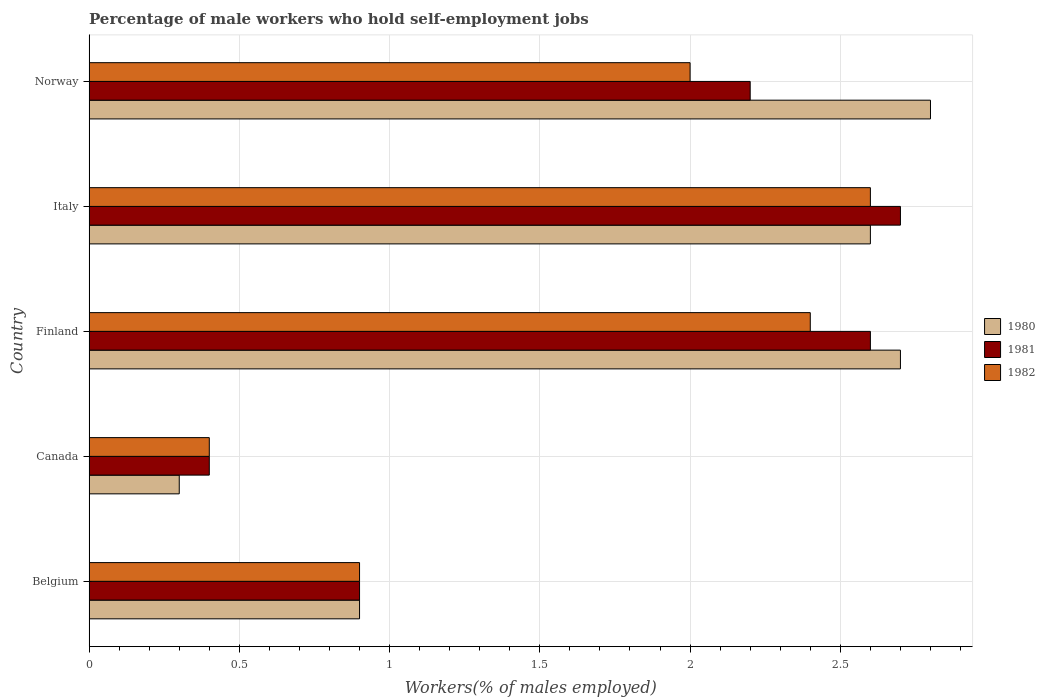How many bars are there on the 2nd tick from the bottom?
Give a very brief answer. 3. What is the label of the 1st group of bars from the top?
Your answer should be very brief. Norway. What is the percentage of self-employed male workers in 1982 in Canada?
Make the answer very short. 0.4. Across all countries, what is the maximum percentage of self-employed male workers in 1982?
Your response must be concise. 2.6. Across all countries, what is the minimum percentage of self-employed male workers in 1980?
Make the answer very short. 0.3. In which country was the percentage of self-employed male workers in 1980 maximum?
Your answer should be very brief. Norway. In which country was the percentage of self-employed male workers in 1981 minimum?
Your response must be concise. Canada. What is the total percentage of self-employed male workers in 1981 in the graph?
Your answer should be compact. 8.8. What is the difference between the percentage of self-employed male workers in 1981 in Belgium and that in Italy?
Your answer should be compact. -1.8. What is the difference between the percentage of self-employed male workers in 1981 in Italy and the percentage of self-employed male workers in 1980 in Norway?
Offer a terse response. -0.1. What is the average percentage of self-employed male workers in 1981 per country?
Make the answer very short. 1.76. What is the difference between the percentage of self-employed male workers in 1981 and percentage of self-employed male workers in 1980 in Norway?
Provide a succinct answer. -0.6. In how many countries, is the percentage of self-employed male workers in 1981 greater than 1.1 %?
Give a very brief answer. 3. What is the ratio of the percentage of self-employed male workers in 1982 in Finland to that in Italy?
Offer a terse response. 0.92. What is the difference between the highest and the second highest percentage of self-employed male workers in 1982?
Keep it short and to the point. 0.2. What is the difference between the highest and the lowest percentage of self-employed male workers in 1981?
Your answer should be very brief. 2.3. In how many countries, is the percentage of self-employed male workers in 1981 greater than the average percentage of self-employed male workers in 1981 taken over all countries?
Your response must be concise. 3. Is the sum of the percentage of self-employed male workers in 1981 in Finland and Norway greater than the maximum percentage of self-employed male workers in 1980 across all countries?
Offer a terse response. Yes. What does the 3rd bar from the bottom in Norway represents?
Provide a succinct answer. 1982. How many countries are there in the graph?
Keep it short and to the point. 5. What is the difference between two consecutive major ticks on the X-axis?
Ensure brevity in your answer.  0.5. Are the values on the major ticks of X-axis written in scientific E-notation?
Your answer should be compact. No. Does the graph contain grids?
Your answer should be very brief. Yes. Where does the legend appear in the graph?
Your answer should be compact. Center right. How are the legend labels stacked?
Give a very brief answer. Vertical. What is the title of the graph?
Provide a short and direct response. Percentage of male workers who hold self-employment jobs. What is the label or title of the X-axis?
Provide a succinct answer. Workers(% of males employed). What is the label or title of the Y-axis?
Offer a very short reply. Country. What is the Workers(% of males employed) in 1980 in Belgium?
Provide a succinct answer. 0.9. What is the Workers(% of males employed) in 1981 in Belgium?
Your answer should be compact. 0.9. What is the Workers(% of males employed) of 1982 in Belgium?
Keep it short and to the point. 0.9. What is the Workers(% of males employed) of 1980 in Canada?
Provide a short and direct response. 0.3. What is the Workers(% of males employed) of 1981 in Canada?
Ensure brevity in your answer.  0.4. What is the Workers(% of males employed) of 1982 in Canada?
Offer a very short reply. 0.4. What is the Workers(% of males employed) of 1980 in Finland?
Ensure brevity in your answer.  2.7. What is the Workers(% of males employed) in 1981 in Finland?
Your answer should be very brief. 2.6. What is the Workers(% of males employed) of 1982 in Finland?
Ensure brevity in your answer.  2.4. What is the Workers(% of males employed) of 1980 in Italy?
Your answer should be compact. 2.6. What is the Workers(% of males employed) in 1981 in Italy?
Your answer should be very brief. 2.7. What is the Workers(% of males employed) of 1982 in Italy?
Keep it short and to the point. 2.6. What is the Workers(% of males employed) in 1980 in Norway?
Make the answer very short. 2.8. What is the Workers(% of males employed) in 1981 in Norway?
Ensure brevity in your answer.  2.2. Across all countries, what is the maximum Workers(% of males employed) in 1980?
Your answer should be very brief. 2.8. Across all countries, what is the maximum Workers(% of males employed) in 1981?
Make the answer very short. 2.7. Across all countries, what is the maximum Workers(% of males employed) in 1982?
Make the answer very short. 2.6. Across all countries, what is the minimum Workers(% of males employed) of 1980?
Ensure brevity in your answer.  0.3. Across all countries, what is the minimum Workers(% of males employed) of 1981?
Offer a terse response. 0.4. Across all countries, what is the minimum Workers(% of males employed) in 1982?
Provide a succinct answer. 0.4. What is the total Workers(% of males employed) of 1980 in the graph?
Give a very brief answer. 9.3. What is the total Workers(% of males employed) in 1981 in the graph?
Provide a short and direct response. 8.8. What is the difference between the Workers(% of males employed) of 1981 in Belgium and that in Canada?
Offer a very short reply. 0.5. What is the difference between the Workers(% of males employed) of 1982 in Belgium and that in Canada?
Your answer should be compact. 0.5. What is the difference between the Workers(% of males employed) of 1981 in Belgium and that in Finland?
Your response must be concise. -1.7. What is the difference between the Workers(% of males employed) of 1982 in Belgium and that in Finland?
Your answer should be very brief. -1.5. What is the difference between the Workers(% of males employed) of 1981 in Belgium and that in Italy?
Offer a very short reply. -1.8. What is the difference between the Workers(% of males employed) of 1981 in Canada and that in Finland?
Keep it short and to the point. -2.2. What is the difference between the Workers(% of males employed) in 1981 in Canada and that in Italy?
Offer a terse response. -2.3. What is the difference between the Workers(% of males employed) of 1982 in Canada and that in Italy?
Your answer should be very brief. -2.2. What is the difference between the Workers(% of males employed) in 1982 in Canada and that in Norway?
Your response must be concise. -1.6. What is the difference between the Workers(% of males employed) in 1981 in Finland and that in Italy?
Ensure brevity in your answer.  -0.1. What is the difference between the Workers(% of males employed) in 1982 in Finland and that in Italy?
Provide a short and direct response. -0.2. What is the difference between the Workers(% of males employed) of 1980 in Finland and that in Norway?
Offer a very short reply. -0.1. What is the difference between the Workers(% of males employed) of 1981 in Italy and that in Norway?
Offer a very short reply. 0.5. What is the difference between the Workers(% of males employed) in 1980 in Belgium and the Workers(% of males employed) in 1981 in Canada?
Offer a very short reply. 0.5. What is the difference between the Workers(% of males employed) in 1981 in Belgium and the Workers(% of males employed) in 1982 in Canada?
Your answer should be very brief. 0.5. What is the difference between the Workers(% of males employed) of 1980 in Belgium and the Workers(% of males employed) of 1981 in Finland?
Make the answer very short. -1.7. What is the difference between the Workers(% of males employed) in 1980 in Belgium and the Workers(% of males employed) in 1982 in Finland?
Your response must be concise. -1.5. What is the difference between the Workers(% of males employed) in 1980 in Belgium and the Workers(% of males employed) in 1981 in Italy?
Provide a short and direct response. -1.8. What is the difference between the Workers(% of males employed) of 1981 in Belgium and the Workers(% of males employed) of 1982 in Italy?
Offer a terse response. -1.7. What is the difference between the Workers(% of males employed) in 1980 in Belgium and the Workers(% of males employed) in 1981 in Norway?
Provide a short and direct response. -1.3. What is the difference between the Workers(% of males employed) of 1981 in Belgium and the Workers(% of males employed) of 1982 in Norway?
Your response must be concise. -1.1. What is the difference between the Workers(% of males employed) of 1980 in Canada and the Workers(% of males employed) of 1981 in Finland?
Provide a short and direct response. -2.3. What is the difference between the Workers(% of males employed) of 1981 in Canada and the Workers(% of males employed) of 1982 in Finland?
Ensure brevity in your answer.  -2. What is the difference between the Workers(% of males employed) of 1980 in Canada and the Workers(% of males employed) of 1981 in Italy?
Make the answer very short. -2.4. What is the difference between the Workers(% of males employed) of 1980 in Finland and the Workers(% of males employed) of 1982 in Norway?
Ensure brevity in your answer.  0.7. What is the difference between the Workers(% of males employed) of 1980 in Italy and the Workers(% of males employed) of 1981 in Norway?
Provide a short and direct response. 0.4. What is the average Workers(% of males employed) in 1980 per country?
Your answer should be compact. 1.86. What is the average Workers(% of males employed) in 1981 per country?
Make the answer very short. 1.76. What is the average Workers(% of males employed) in 1982 per country?
Give a very brief answer. 1.66. What is the difference between the Workers(% of males employed) of 1980 and Workers(% of males employed) of 1982 in Finland?
Provide a short and direct response. 0.3. What is the difference between the Workers(% of males employed) in 1981 and Workers(% of males employed) in 1982 in Finland?
Provide a short and direct response. 0.2. What is the difference between the Workers(% of males employed) in 1980 and Workers(% of males employed) in 1981 in Italy?
Make the answer very short. -0.1. What is the difference between the Workers(% of males employed) in 1980 and Workers(% of males employed) in 1982 in Norway?
Your answer should be very brief. 0.8. What is the ratio of the Workers(% of males employed) in 1980 in Belgium to that in Canada?
Provide a succinct answer. 3. What is the ratio of the Workers(% of males employed) of 1981 in Belgium to that in Canada?
Give a very brief answer. 2.25. What is the ratio of the Workers(% of males employed) of 1982 in Belgium to that in Canada?
Offer a very short reply. 2.25. What is the ratio of the Workers(% of males employed) of 1981 in Belgium to that in Finland?
Provide a short and direct response. 0.35. What is the ratio of the Workers(% of males employed) of 1980 in Belgium to that in Italy?
Ensure brevity in your answer.  0.35. What is the ratio of the Workers(% of males employed) in 1981 in Belgium to that in Italy?
Offer a terse response. 0.33. What is the ratio of the Workers(% of males employed) of 1982 in Belgium to that in Italy?
Your answer should be compact. 0.35. What is the ratio of the Workers(% of males employed) of 1980 in Belgium to that in Norway?
Make the answer very short. 0.32. What is the ratio of the Workers(% of males employed) of 1981 in Belgium to that in Norway?
Give a very brief answer. 0.41. What is the ratio of the Workers(% of males employed) in 1982 in Belgium to that in Norway?
Your response must be concise. 0.45. What is the ratio of the Workers(% of males employed) in 1981 in Canada to that in Finland?
Your response must be concise. 0.15. What is the ratio of the Workers(% of males employed) in 1982 in Canada to that in Finland?
Your response must be concise. 0.17. What is the ratio of the Workers(% of males employed) in 1980 in Canada to that in Italy?
Give a very brief answer. 0.12. What is the ratio of the Workers(% of males employed) of 1981 in Canada to that in Italy?
Your answer should be compact. 0.15. What is the ratio of the Workers(% of males employed) of 1982 in Canada to that in Italy?
Give a very brief answer. 0.15. What is the ratio of the Workers(% of males employed) of 1980 in Canada to that in Norway?
Offer a very short reply. 0.11. What is the ratio of the Workers(% of males employed) of 1981 in Canada to that in Norway?
Keep it short and to the point. 0.18. What is the ratio of the Workers(% of males employed) of 1982 in Canada to that in Norway?
Offer a terse response. 0.2. What is the ratio of the Workers(% of males employed) of 1980 in Finland to that in Italy?
Make the answer very short. 1.04. What is the ratio of the Workers(% of males employed) of 1981 in Finland to that in Norway?
Keep it short and to the point. 1.18. What is the ratio of the Workers(% of males employed) of 1982 in Finland to that in Norway?
Your answer should be compact. 1.2. What is the ratio of the Workers(% of males employed) of 1980 in Italy to that in Norway?
Keep it short and to the point. 0.93. What is the ratio of the Workers(% of males employed) of 1981 in Italy to that in Norway?
Give a very brief answer. 1.23. What is the difference between the highest and the second highest Workers(% of males employed) of 1980?
Offer a very short reply. 0.1. What is the difference between the highest and the second highest Workers(% of males employed) of 1982?
Offer a terse response. 0.2. What is the difference between the highest and the lowest Workers(% of males employed) in 1981?
Your answer should be very brief. 2.3. What is the difference between the highest and the lowest Workers(% of males employed) in 1982?
Your answer should be very brief. 2.2. 